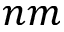Convert formula to latex. <formula><loc_0><loc_0><loc_500><loc_500>n m</formula> 